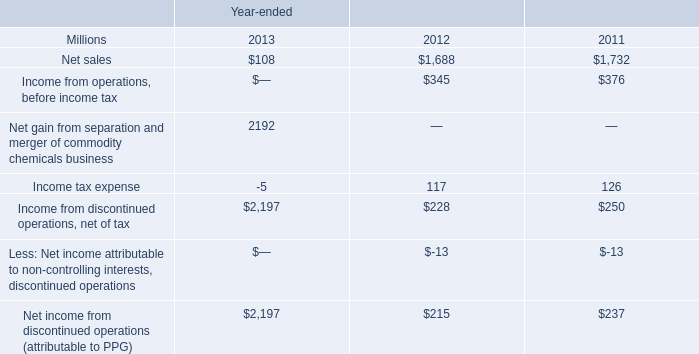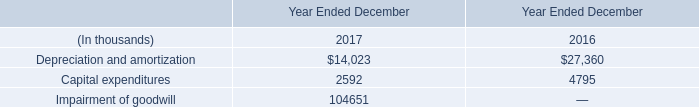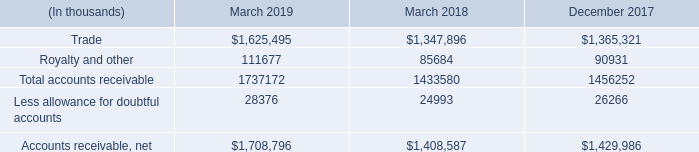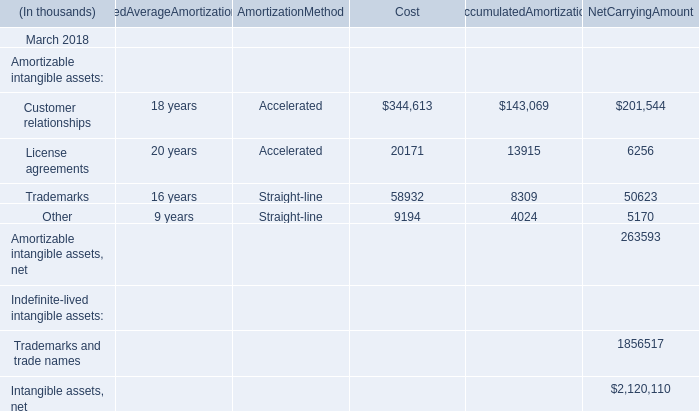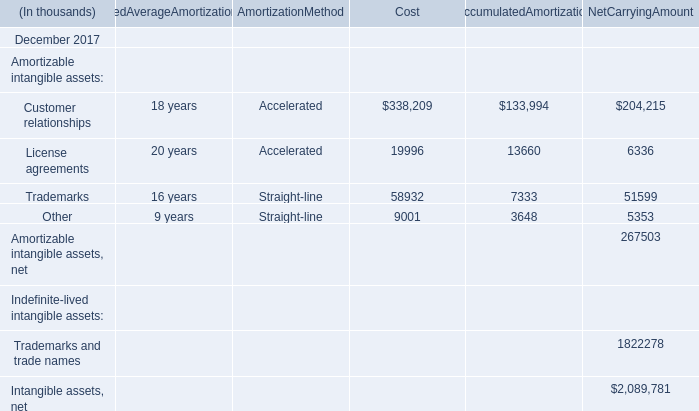What's the sum of Customer relationships of NetCarryingAmount, and Less allowance for doubtful accounts of December 2017 ? 
Computations: (204215.0 + 26266.0)
Answer: 230481.0. 